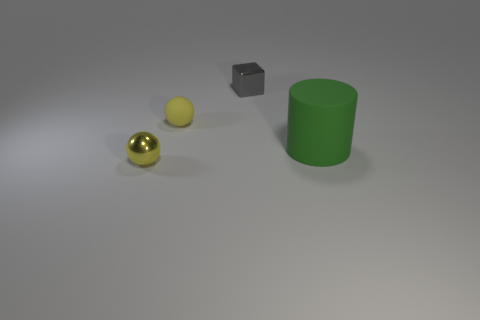Add 1 small balls. How many objects exist? 5 Subtract all cubes. How many objects are left? 3 Subtract all small green matte blocks. Subtract all shiny spheres. How many objects are left? 3 Add 4 rubber objects. How many rubber objects are left? 6 Add 4 small cyan matte cylinders. How many small cyan matte cylinders exist? 4 Subtract 1 yellow balls. How many objects are left? 3 Subtract 1 cylinders. How many cylinders are left? 0 Subtract all gray spheres. Subtract all purple cubes. How many spheres are left? 2 